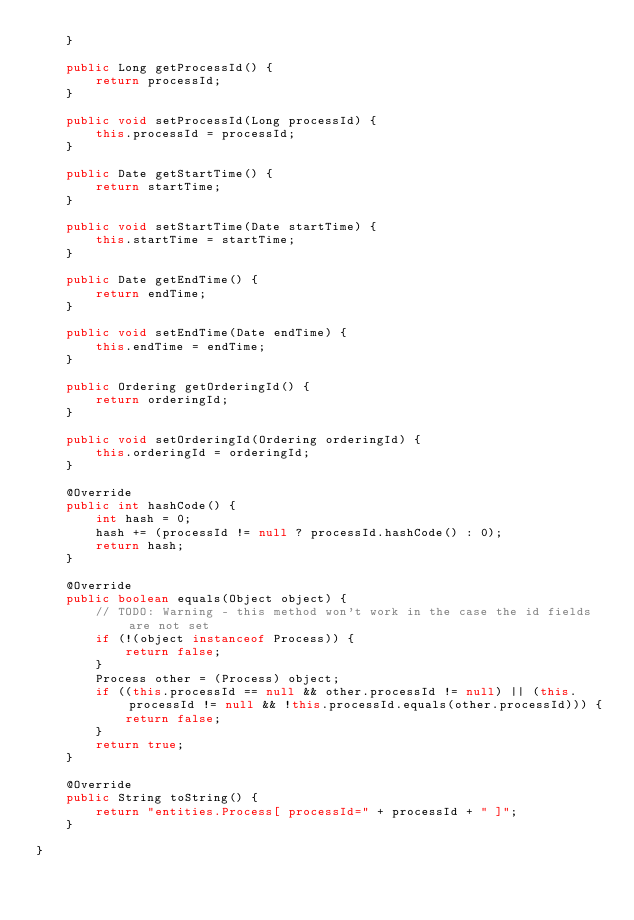Convert code to text. <code><loc_0><loc_0><loc_500><loc_500><_Java_>    }

    public Long getProcessId() {
        return processId;
    }

    public void setProcessId(Long processId) {
        this.processId = processId;
    }

    public Date getStartTime() {
        return startTime;
    }

    public void setStartTime(Date startTime) {
        this.startTime = startTime;
    }

    public Date getEndTime() {
        return endTime;
    }

    public void setEndTime(Date endTime) {
        this.endTime = endTime;
    }

    public Ordering getOrderingId() {
        return orderingId;
    }

    public void setOrderingId(Ordering orderingId) {
        this.orderingId = orderingId;
    }

    @Override
    public int hashCode() {
        int hash = 0;
        hash += (processId != null ? processId.hashCode() : 0);
        return hash;
    }

    @Override
    public boolean equals(Object object) {
        // TODO: Warning - this method won't work in the case the id fields are not set
        if (!(object instanceof Process)) {
            return false;
        }
        Process other = (Process) object;
        if ((this.processId == null && other.processId != null) || (this.processId != null && !this.processId.equals(other.processId))) {
            return false;
        }
        return true;
    }

    @Override
    public String toString() {
        return "entities.Process[ processId=" + processId + " ]";
    }
    
}
</code> 